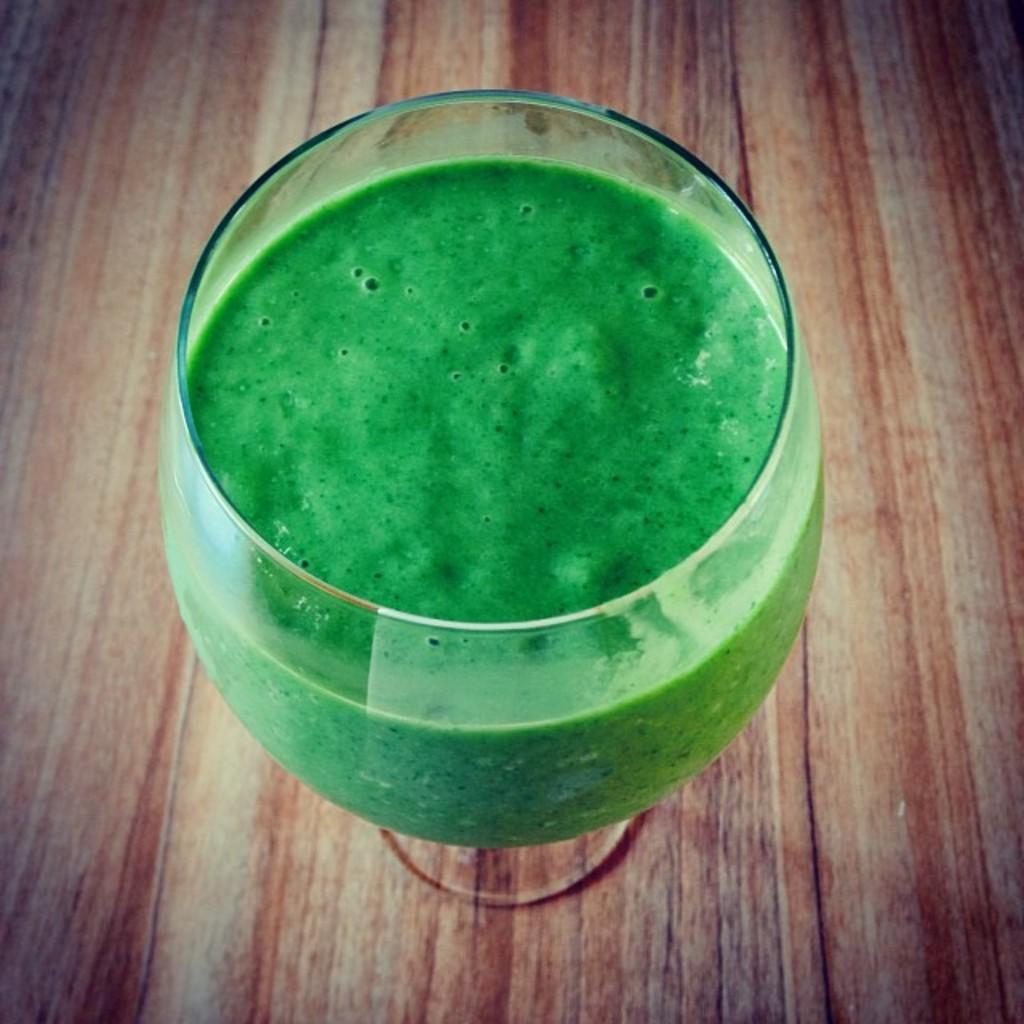Can you describe this image briefly? In this picture we can see green thick liquid in a glass. A glass is placed on a wooden platform. 